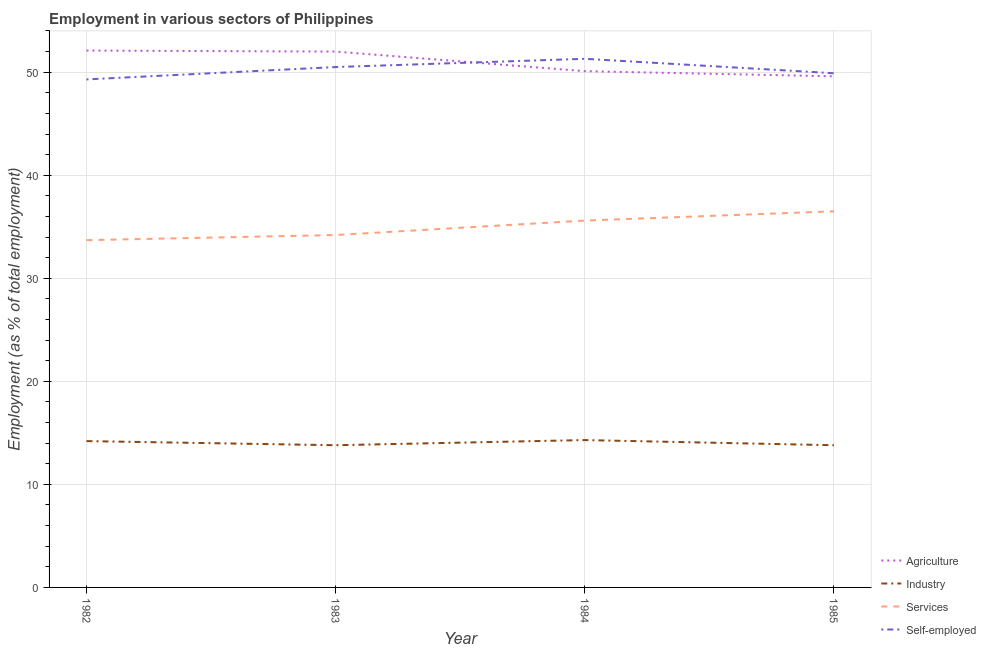Is the number of lines equal to the number of legend labels?
Your answer should be compact. Yes. What is the percentage of workers in agriculture in 1983?
Provide a short and direct response. 52. Across all years, what is the maximum percentage of workers in services?
Ensure brevity in your answer.  36.5. Across all years, what is the minimum percentage of self employed workers?
Keep it short and to the point. 49.3. What is the total percentage of workers in services in the graph?
Offer a very short reply. 140. What is the difference between the percentage of self employed workers in 1982 and that in 1984?
Your response must be concise. -2. What is the difference between the percentage of workers in agriculture in 1985 and the percentage of self employed workers in 1983?
Your response must be concise. -0.9. What is the average percentage of workers in services per year?
Provide a succinct answer. 35. In the year 1982, what is the difference between the percentage of workers in industry and percentage of workers in services?
Your answer should be very brief. -19.5. What is the ratio of the percentage of workers in industry in 1982 to that in 1984?
Offer a very short reply. 0.99. Is the percentage of workers in agriculture in 1982 less than that in 1983?
Provide a short and direct response. No. What is the difference between the highest and the second highest percentage of self employed workers?
Provide a short and direct response. 0.8. What is the difference between the highest and the lowest percentage of workers in services?
Your response must be concise. 2.8. In how many years, is the percentage of self employed workers greater than the average percentage of self employed workers taken over all years?
Your response must be concise. 2. Is the sum of the percentage of workers in industry in 1984 and 1985 greater than the maximum percentage of self employed workers across all years?
Ensure brevity in your answer.  No. Is it the case that in every year, the sum of the percentage of self employed workers and percentage of workers in agriculture is greater than the sum of percentage of workers in services and percentage of workers in industry?
Give a very brief answer. Yes. Is it the case that in every year, the sum of the percentage of workers in agriculture and percentage of workers in industry is greater than the percentage of workers in services?
Ensure brevity in your answer.  Yes. Does the percentage of workers in industry monotonically increase over the years?
Your response must be concise. No. Is the percentage of workers in industry strictly less than the percentage of self employed workers over the years?
Keep it short and to the point. Yes. What is the difference between two consecutive major ticks on the Y-axis?
Provide a succinct answer. 10. Are the values on the major ticks of Y-axis written in scientific E-notation?
Make the answer very short. No. Does the graph contain any zero values?
Provide a succinct answer. No. How many legend labels are there?
Keep it short and to the point. 4. How are the legend labels stacked?
Ensure brevity in your answer.  Vertical. What is the title of the graph?
Keep it short and to the point. Employment in various sectors of Philippines. What is the label or title of the Y-axis?
Make the answer very short. Employment (as % of total employment). What is the Employment (as % of total employment) of Agriculture in 1982?
Give a very brief answer. 52.1. What is the Employment (as % of total employment) in Industry in 1982?
Your answer should be compact. 14.2. What is the Employment (as % of total employment) in Services in 1982?
Provide a succinct answer. 33.7. What is the Employment (as % of total employment) in Self-employed in 1982?
Make the answer very short. 49.3. What is the Employment (as % of total employment) of Agriculture in 1983?
Provide a succinct answer. 52. What is the Employment (as % of total employment) of Industry in 1983?
Your answer should be very brief. 13.8. What is the Employment (as % of total employment) in Services in 1983?
Make the answer very short. 34.2. What is the Employment (as % of total employment) in Self-employed in 1983?
Your answer should be compact. 50.5. What is the Employment (as % of total employment) in Agriculture in 1984?
Make the answer very short. 50.1. What is the Employment (as % of total employment) of Industry in 1984?
Provide a succinct answer. 14.3. What is the Employment (as % of total employment) of Services in 1984?
Make the answer very short. 35.6. What is the Employment (as % of total employment) in Self-employed in 1984?
Provide a succinct answer. 51.3. What is the Employment (as % of total employment) in Agriculture in 1985?
Make the answer very short. 49.6. What is the Employment (as % of total employment) of Industry in 1985?
Provide a short and direct response. 13.8. What is the Employment (as % of total employment) in Services in 1985?
Provide a succinct answer. 36.5. What is the Employment (as % of total employment) of Self-employed in 1985?
Make the answer very short. 49.9. Across all years, what is the maximum Employment (as % of total employment) in Agriculture?
Provide a succinct answer. 52.1. Across all years, what is the maximum Employment (as % of total employment) of Industry?
Keep it short and to the point. 14.3. Across all years, what is the maximum Employment (as % of total employment) in Services?
Offer a very short reply. 36.5. Across all years, what is the maximum Employment (as % of total employment) of Self-employed?
Offer a very short reply. 51.3. Across all years, what is the minimum Employment (as % of total employment) in Agriculture?
Your answer should be very brief. 49.6. Across all years, what is the minimum Employment (as % of total employment) of Industry?
Your answer should be very brief. 13.8. Across all years, what is the minimum Employment (as % of total employment) in Services?
Give a very brief answer. 33.7. Across all years, what is the minimum Employment (as % of total employment) of Self-employed?
Your answer should be compact. 49.3. What is the total Employment (as % of total employment) in Agriculture in the graph?
Offer a very short reply. 203.8. What is the total Employment (as % of total employment) of Industry in the graph?
Your response must be concise. 56.1. What is the total Employment (as % of total employment) in Services in the graph?
Offer a terse response. 140. What is the total Employment (as % of total employment) in Self-employed in the graph?
Provide a succinct answer. 201. What is the difference between the Employment (as % of total employment) of Agriculture in 1982 and that in 1983?
Provide a succinct answer. 0.1. What is the difference between the Employment (as % of total employment) of Self-employed in 1982 and that in 1983?
Make the answer very short. -1.2. What is the difference between the Employment (as % of total employment) in Agriculture in 1982 and that in 1984?
Offer a terse response. 2. What is the difference between the Employment (as % of total employment) in Industry in 1982 and that in 1984?
Ensure brevity in your answer.  -0.1. What is the difference between the Employment (as % of total employment) in Agriculture in 1982 and that in 1985?
Give a very brief answer. 2.5. What is the difference between the Employment (as % of total employment) in Industry in 1982 and that in 1985?
Keep it short and to the point. 0.4. What is the difference between the Employment (as % of total employment) of Services in 1982 and that in 1985?
Your response must be concise. -2.8. What is the difference between the Employment (as % of total employment) of Self-employed in 1982 and that in 1985?
Offer a terse response. -0.6. What is the difference between the Employment (as % of total employment) of Services in 1983 and that in 1984?
Make the answer very short. -1.4. What is the difference between the Employment (as % of total employment) in Self-employed in 1983 and that in 1984?
Make the answer very short. -0.8. What is the difference between the Employment (as % of total employment) of Industry in 1983 and that in 1985?
Offer a very short reply. 0. What is the difference between the Employment (as % of total employment) in Services in 1983 and that in 1985?
Make the answer very short. -2.3. What is the difference between the Employment (as % of total employment) of Self-employed in 1983 and that in 1985?
Your answer should be very brief. 0.6. What is the difference between the Employment (as % of total employment) of Agriculture in 1984 and that in 1985?
Give a very brief answer. 0.5. What is the difference between the Employment (as % of total employment) in Services in 1984 and that in 1985?
Your response must be concise. -0.9. What is the difference between the Employment (as % of total employment) of Self-employed in 1984 and that in 1985?
Offer a terse response. 1.4. What is the difference between the Employment (as % of total employment) in Agriculture in 1982 and the Employment (as % of total employment) in Industry in 1983?
Your answer should be compact. 38.3. What is the difference between the Employment (as % of total employment) of Agriculture in 1982 and the Employment (as % of total employment) of Services in 1983?
Ensure brevity in your answer.  17.9. What is the difference between the Employment (as % of total employment) in Industry in 1982 and the Employment (as % of total employment) in Self-employed in 1983?
Offer a very short reply. -36.3. What is the difference between the Employment (as % of total employment) of Services in 1982 and the Employment (as % of total employment) of Self-employed in 1983?
Your response must be concise. -16.8. What is the difference between the Employment (as % of total employment) of Agriculture in 1982 and the Employment (as % of total employment) of Industry in 1984?
Offer a terse response. 37.8. What is the difference between the Employment (as % of total employment) in Agriculture in 1982 and the Employment (as % of total employment) in Self-employed in 1984?
Your answer should be very brief. 0.8. What is the difference between the Employment (as % of total employment) of Industry in 1982 and the Employment (as % of total employment) of Services in 1984?
Give a very brief answer. -21.4. What is the difference between the Employment (as % of total employment) of Industry in 1982 and the Employment (as % of total employment) of Self-employed in 1984?
Provide a short and direct response. -37.1. What is the difference between the Employment (as % of total employment) in Services in 1982 and the Employment (as % of total employment) in Self-employed in 1984?
Provide a succinct answer. -17.6. What is the difference between the Employment (as % of total employment) of Agriculture in 1982 and the Employment (as % of total employment) of Industry in 1985?
Provide a short and direct response. 38.3. What is the difference between the Employment (as % of total employment) in Agriculture in 1982 and the Employment (as % of total employment) in Self-employed in 1985?
Offer a very short reply. 2.2. What is the difference between the Employment (as % of total employment) in Industry in 1982 and the Employment (as % of total employment) in Services in 1985?
Provide a short and direct response. -22.3. What is the difference between the Employment (as % of total employment) of Industry in 1982 and the Employment (as % of total employment) of Self-employed in 1985?
Ensure brevity in your answer.  -35.7. What is the difference between the Employment (as % of total employment) in Services in 1982 and the Employment (as % of total employment) in Self-employed in 1985?
Offer a terse response. -16.2. What is the difference between the Employment (as % of total employment) in Agriculture in 1983 and the Employment (as % of total employment) in Industry in 1984?
Keep it short and to the point. 37.7. What is the difference between the Employment (as % of total employment) in Agriculture in 1983 and the Employment (as % of total employment) in Services in 1984?
Your answer should be very brief. 16.4. What is the difference between the Employment (as % of total employment) of Industry in 1983 and the Employment (as % of total employment) of Services in 1984?
Keep it short and to the point. -21.8. What is the difference between the Employment (as % of total employment) in Industry in 1983 and the Employment (as % of total employment) in Self-employed in 1984?
Provide a succinct answer. -37.5. What is the difference between the Employment (as % of total employment) of Services in 1983 and the Employment (as % of total employment) of Self-employed in 1984?
Your response must be concise. -17.1. What is the difference between the Employment (as % of total employment) in Agriculture in 1983 and the Employment (as % of total employment) in Industry in 1985?
Offer a very short reply. 38.2. What is the difference between the Employment (as % of total employment) in Industry in 1983 and the Employment (as % of total employment) in Services in 1985?
Give a very brief answer. -22.7. What is the difference between the Employment (as % of total employment) of Industry in 1983 and the Employment (as % of total employment) of Self-employed in 1985?
Your answer should be very brief. -36.1. What is the difference between the Employment (as % of total employment) of Services in 1983 and the Employment (as % of total employment) of Self-employed in 1985?
Provide a short and direct response. -15.7. What is the difference between the Employment (as % of total employment) in Agriculture in 1984 and the Employment (as % of total employment) in Industry in 1985?
Offer a very short reply. 36.3. What is the difference between the Employment (as % of total employment) of Agriculture in 1984 and the Employment (as % of total employment) of Self-employed in 1985?
Give a very brief answer. 0.2. What is the difference between the Employment (as % of total employment) of Industry in 1984 and the Employment (as % of total employment) of Services in 1985?
Ensure brevity in your answer.  -22.2. What is the difference between the Employment (as % of total employment) in Industry in 1984 and the Employment (as % of total employment) in Self-employed in 1985?
Provide a succinct answer. -35.6. What is the difference between the Employment (as % of total employment) of Services in 1984 and the Employment (as % of total employment) of Self-employed in 1985?
Ensure brevity in your answer.  -14.3. What is the average Employment (as % of total employment) in Agriculture per year?
Provide a succinct answer. 50.95. What is the average Employment (as % of total employment) of Industry per year?
Give a very brief answer. 14.03. What is the average Employment (as % of total employment) of Services per year?
Offer a terse response. 35. What is the average Employment (as % of total employment) of Self-employed per year?
Your response must be concise. 50.25. In the year 1982, what is the difference between the Employment (as % of total employment) of Agriculture and Employment (as % of total employment) of Industry?
Offer a terse response. 37.9. In the year 1982, what is the difference between the Employment (as % of total employment) of Agriculture and Employment (as % of total employment) of Self-employed?
Ensure brevity in your answer.  2.8. In the year 1982, what is the difference between the Employment (as % of total employment) in Industry and Employment (as % of total employment) in Services?
Your answer should be compact. -19.5. In the year 1982, what is the difference between the Employment (as % of total employment) of Industry and Employment (as % of total employment) of Self-employed?
Provide a short and direct response. -35.1. In the year 1982, what is the difference between the Employment (as % of total employment) of Services and Employment (as % of total employment) of Self-employed?
Offer a terse response. -15.6. In the year 1983, what is the difference between the Employment (as % of total employment) of Agriculture and Employment (as % of total employment) of Industry?
Offer a very short reply. 38.2. In the year 1983, what is the difference between the Employment (as % of total employment) of Agriculture and Employment (as % of total employment) of Services?
Offer a terse response. 17.8. In the year 1983, what is the difference between the Employment (as % of total employment) in Industry and Employment (as % of total employment) in Services?
Ensure brevity in your answer.  -20.4. In the year 1983, what is the difference between the Employment (as % of total employment) of Industry and Employment (as % of total employment) of Self-employed?
Your answer should be compact. -36.7. In the year 1983, what is the difference between the Employment (as % of total employment) in Services and Employment (as % of total employment) in Self-employed?
Provide a short and direct response. -16.3. In the year 1984, what is the difference between the Employment (as % of total employment) in Agriculture and Employment (as % of total employment) in Industry?
Offer a terse response. 35.8. In the year 1984, what is the difference between the Employment (as % of total employment) in Agriculture and Employment (as % of total employment) in Services?
Ensure brevity in your answer.  14.5. In the year 1984, what is the difference between the Employment (as % of total employment) of Agriculture and Employment (as % of total employment) of Self-employed?
Provide a succinct answer. -1.2. In the year 1984, what is the difference between the Employment (as % of total employment) in Industry and Employment (as % of total employment) in Services?
Your answer should be compact. -21.3. In the year 1984, what is the difference between the Employment (as % of total employment) in Industry and Employment (as % of total employment) in Self-employed?
Your answer should be compact. -37. In the year 1984, what is the difference between the Employment (as % of total employment) of Services and Employment (as % of total employment) of Self-employed?
Provide a succinct answer. -15.7. In the year 1985, what is the difference between the Employment (as % of total employment) in Agriculture and Employment (as % of total employment) in Industry?
Offer a very short reply. 35.8. In the year 1985, what is the difference between the Employment (as % of total employment) in Industry and Employment (as % of total employment) in Services?
Your answer should be compact. -22.7. In the year 1985, what is the difference between the Employment (as % of total employment) of Industry and Employment (as % of total employment) of Self-employed?
Your answer should be very brief. -36.1. What is the ratio of the Employment (as % of total employment) in Industry in 1982 to that in 1983?
Offer a very short reply. 1.03. What is the ratio of the Employment (as % of total employment) in Services in 1982 to that in 1983?
Make the answer very short. 0.99. What is the ratio of the Employment (as % of total employment) of Self-employed in 1982 to that in 1983?
Give a very brief answer. 0.98. What is the ratio of the Employment (as % of total employment) of Agriculture in 1982 to that in 1984?
Keep it short and to the point. 1.04. What is the ratio of the Employment (as % of total employment) in Services in 1982 to that in 1984?
Provide a succinct answer. 0.95. What is the ratio of the Employment (as % of total employment) of Self-employed in 1982 to that in 1984?
Provide a succinct answer. 0.96. What is the ratio of the Employment (as % of total employment) in Agriculture in 1982 to that in 1985?
Provide a short and direct response. 1.05. What is the ratio of the Employment (as % of total employment) of Industry in 1982 to that in 1985?
Provide a short and direct response. 1.03. What is the ratio of the Employment (as % of total employment) of Services in 1982 to that in 1985?
Provide a succinct answer. 0.92. What is the ratio of the Employment (as % of total employment) of Self-employed in 1982 to that in 1985?
Your answer should be compact. 0.99. What is the ratio of the Employment (as % of total employment) of Agriculture in 1983 to that in 1984?
Ensure brevity in your answer.  1.04. What is the ratio of the Employment (as % of total employment) of Services in 1983 to that in 1984?
Offer a terse response. 0.96. What is the ratio of the Employment (as % of total employment) of Self-employed in 1983 to that in 1984?
Provide a short and direct response. 0.98. What is the ratio of the Employment (as % of total employment) in Agriculture in 1983 to that in 1985?
Provide a succinct answer. 1.05. What is the ratio of the Employment (as % of total employment) of Industry in 1983 to that in 1985?
Give a very brief answer. 1. What is the ratio of the Employment (as % of total employment) in Services in 1983 to that in 1985?
Offer a terse response. 0.94. What is the ratio of the Employment (as % of total employment) in Self-employed in 1983 to that in 1985?
Give a very brief answer. 1.01. What is the ratio of the Employment (as % of total employment) of Industry in 1984 to that in 1985?
Offer a terse response. 1.04. What is the ratio of the Employment (as % of total employment) of Services in 1984 to that in 1985?
Provide a short and direct response. 0.98. What is the ratio of the Employment (as % of total employment) of Self-employed in 1984 to that in 1985?
Your answer should be very brief. 1.03. What is the difference between the highest and the second highest Employment (as % of total employment) of Agriculture?
Offer a very short reply. 0.1. What is the difference between the highest and the second highest Employment (as % of total employment) in Services?
Offer a very short reply. 0.9. What is the difference between the highest and the second highest Employment (as % of total employment) in Self-employed?
Make the answer very short. 0.8. What is the difference between the highest and the lowest Employment (as % of total employment) in Agriculture?
Provide a short and direct response. 2.5. What is the difference between the highest and the lowest Employment (as % of total employment) of Self-employed?
Provide a succinct answer. 2. 